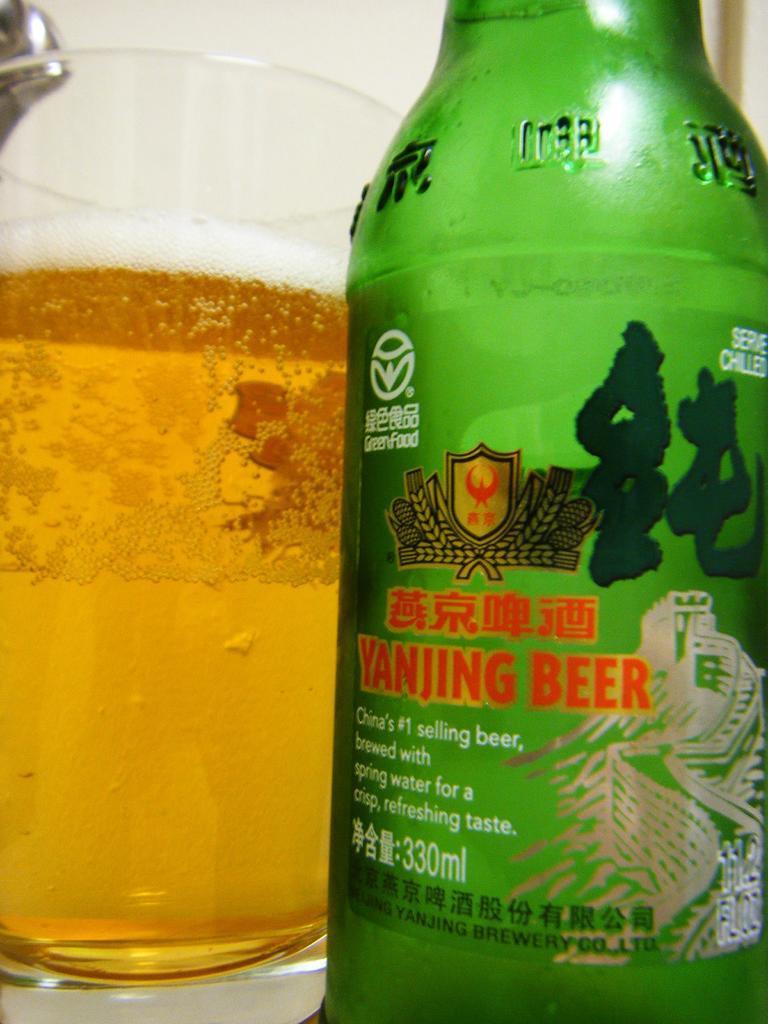In one or two sentences, can you explain what this image depicts? We can able to see a glass with liquid, inside this glass there is a bottle with sticker. 